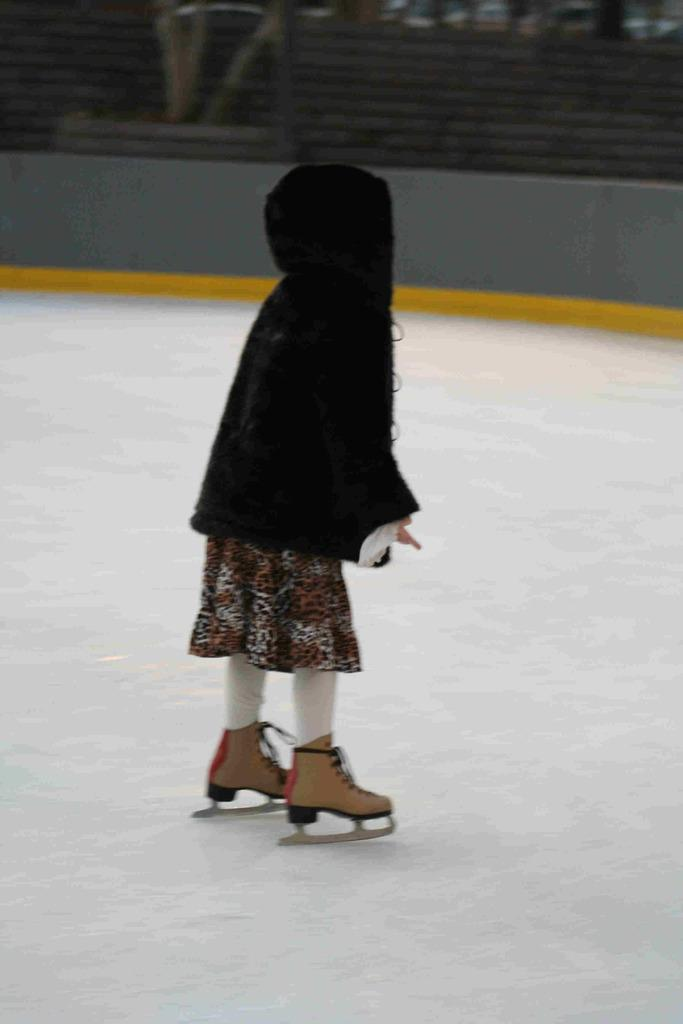What is the main subject of the image? There is a person in the image. What is the person doing in the image? The person is skating. What can be seen beneath the person in the image? The ground is visible in the image. How would you describe the background of the image? The background of the image is blurred. What type of music is the person listening to while skating in the image? There is no indication in the image that the person is listening to music, so it cannot be determined from the picture. 